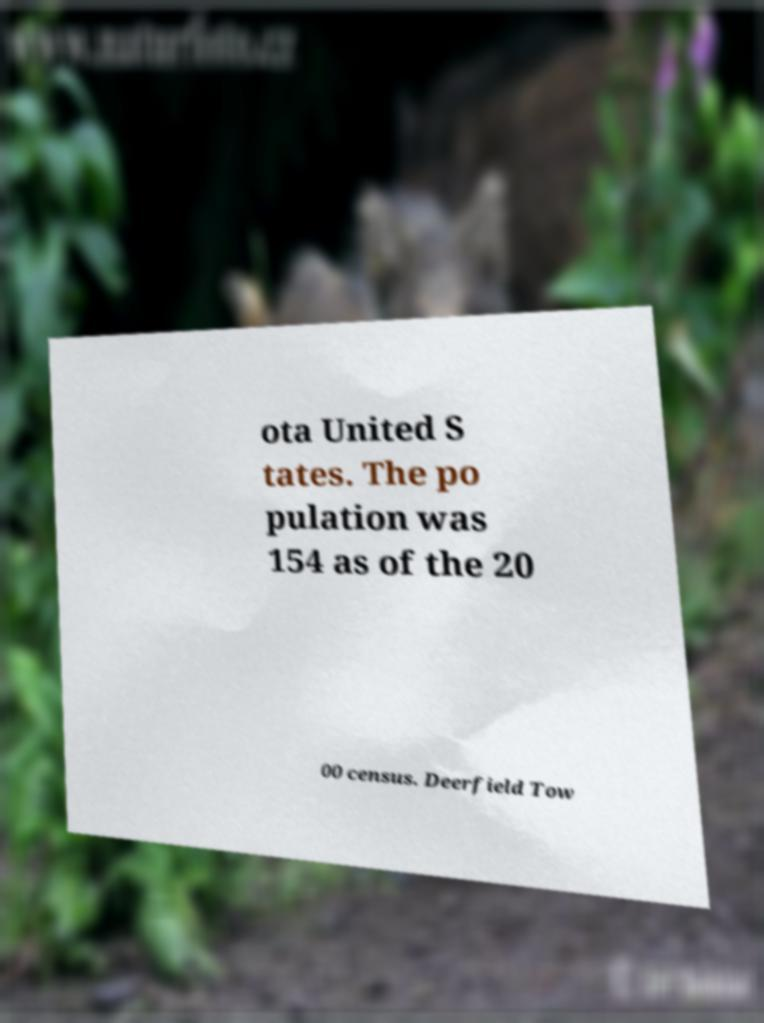What messages or text are displayed in this image? I need them in a readable, typed format. ota United S tates. The po pulation was 154 as of the 20 00 census. Deerfield Tow 